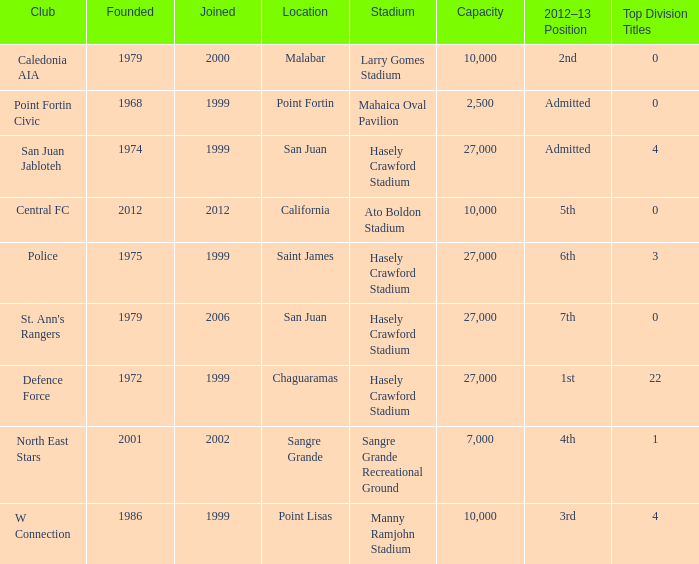Could you parse the entire table? {'header': ['Club', 'Founded', 'Joined', 'Location', 'Stadium', 'Capacity', '2012–13 Position', 'Top Division Titles'], 'rows': [['Caledonia AIA', '1979', '2000', 'Malabar', 'Larry Gomes Stadium', '10,000', '2nd', '0'], ['Point Fortin Civic', '1968', '1999', 'Point Fortin', 'Mahaica Oval Pavilion', '2,500', 'Admitted', '0'], ['San Juan Jabloteh', '1974', '1999', 'San Juan', 'Hasely Crawford Stadium', '27,000', 'Admitted', '4'], ['Central FC', '2012', '2012', 'California', 'Ato Boldon Stadium', '10,000', '5th', '0'], ['Police', '1975', '1999', 'Saint James', 'Hasely Crawford Stadium', '27,000', '6th', '3'], ["St. Ann's Rangers", '1979', '2006', 'San Juan', 'Hasely Crawford Stadium', '27,000', '7th', '0'], ['Defence Force', '1972', '1999', 'Chaguaramas', 'Hasely Crawford Stadium', '27,000', '1st', '22'], ['North East Stars', '2001', '2002', 'Sangre Grande', 'Sangre Grande Recreational Ground', '7,000', '4th', '1'], ['W Connection', '1986', '1999', 'Point Lisas', 'Manny Ramjohn Stadium', '10,000', '3rd', '4']]} What was the total number of Top Division Titles where the year founded was prior to 1975 and the location was in Chaguaramas? 22.0. 